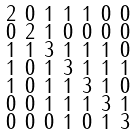Convert formula to latex. <formula><loc_0><loc_0><loc_500><loc_500>\begin{smallmatrix} 2 & 0 & 1 & 1 & 1 & 0 & 0 \\ 0 & 2 & 1 & 0 & 0 & 0 & 0 \\ 1 & 1 & 3 & 1 & 1 & 1 & 0 \\ 1 & 0 & 1 & 3 & 1 & 1 & 1 \\ 1 & 0 & 1 & 1 & 3 & 1 & 0 \\ 0 & 0 & 1 & 1 & 1 & 3 & 1 \\ 0 & 0 & 0 & 1 & 0 & 1 & 3 \end{smallmatrix}</formula> 